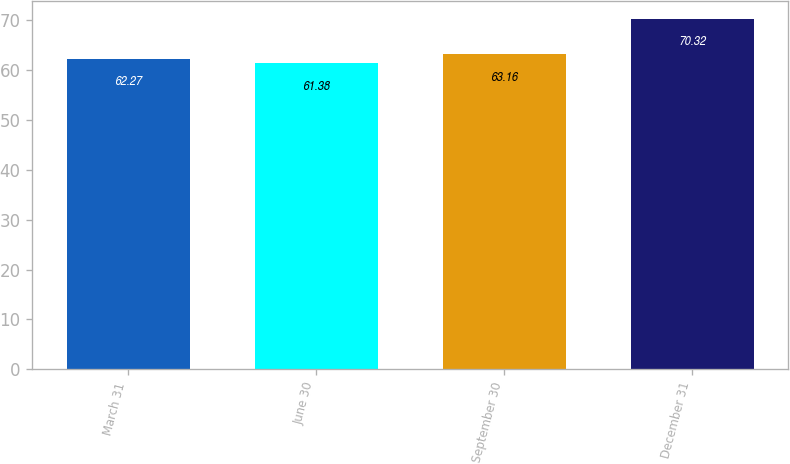Convert chart. <chart><loc_0><loc_0><loc_500><loc_500><bar_chart><fcel>March 31<fcel>June 30<fcel>September 30<fcel>December 31<nl><fcel>62.27<fcel>61.38<fcel>63.16<fcel>70.32<nl></chart> 